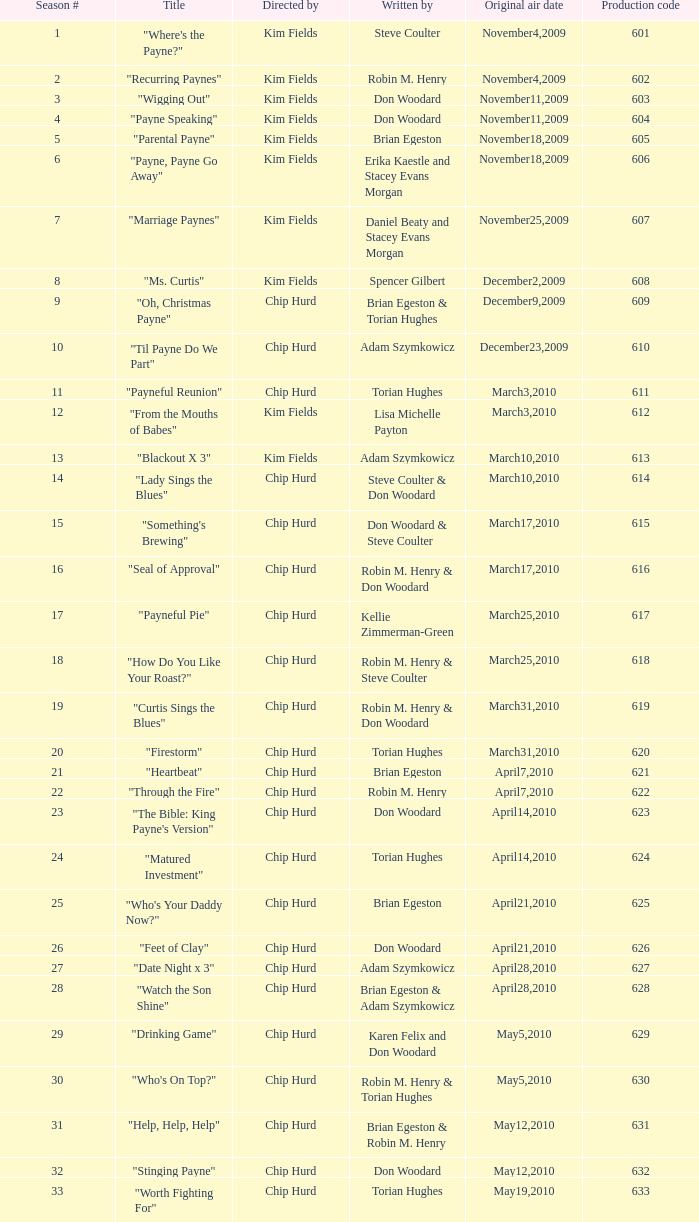What are the premiere air dates for the title "firestorm"? March31,2010. 